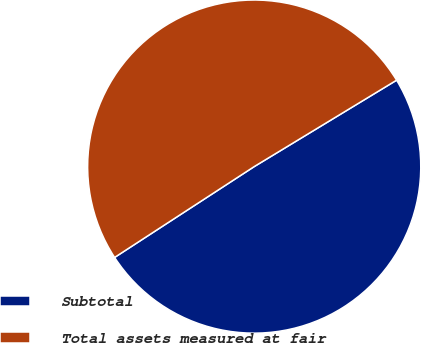Convert chart. <chart><loc_0><loc_0><loc_500><loc_500><pie_chart><fcel>Subtotal<fcel>Total assets measured at fair<nl><fcel>49.5%<fcel>50.5%<nl></chart> 